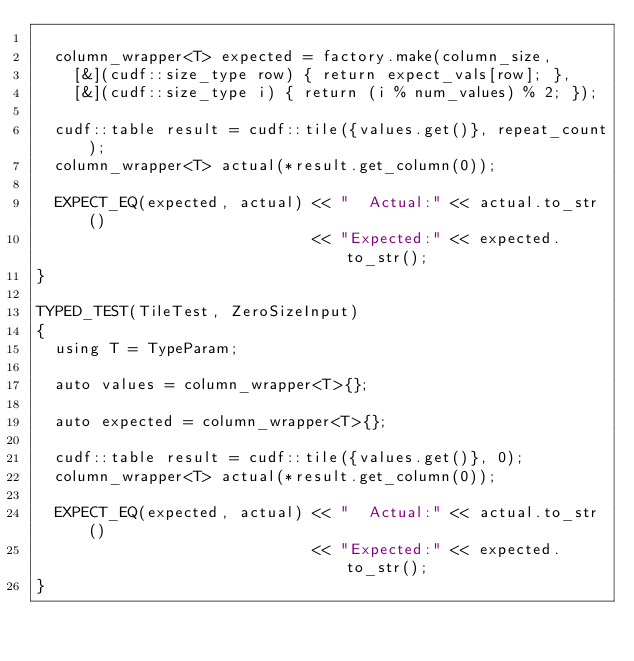<code> <loc_0><loc_0><loc_500><loc_500><_Cuda_>
  column_wrapper<T> expected = factory.make(column_size,
    [&](cudf::size_type row) { return expect_vals[row]; },
    [&](cudf::size_type i) { return (i % num_values) % 2; });

  cudf::table result = cudf::tile({values.get()}, repeat_count);
  column_wrapper<T> actual(*result.get_column(0));

  EXPECT_EQ(expected, actual) << "  Actual:" << actual.to_str()
                              << "Expected:" << expected.to_str();
}

TYPED_TEST(TileTest, ZeroSizeInput)
{
  using T = TypeParam;

  auto values = column_wrapper<T>{};

  auto expected = column_wrapper<T>{};

  cudf::table result = cudf::tile({values.get()}, 0);
  column_wrapper<T> actual(*result.get_column(0));

  EXPECT_EQ(expected, actual) << "  Actual:" << actual.to_str()
                              << "Expected:" << expected.to_str();
}
</code> 